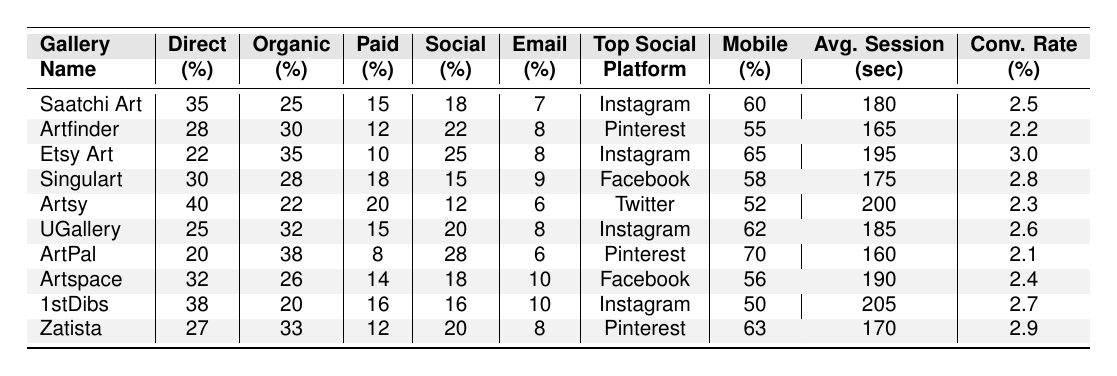What is the direct traffic percentage for Etsy Art? Referring to the table, the direct traffic percentage for Etsy Art is 22%.
Answer: 22% Which gallery has the highest percentage of organic search traffic? By examining the organic search traffic, Etsy Art has the highest percentage at 35%.
Answer: 35% What's the average conversion rate for all the galleries listed? To find the average conversion rate, sum all conversion rates: (2.5 + 2.2 + 3.0 + 2.8 + 2.3 + 2.6 + 2.1 + 2.4 + 2.7 + 2.9) = 27.0 and divide by 10, which equals 2.7.
Answer: 2.7 Is the top social media platform for Saatchi Art Instagram? Yes, the table indicates that the top social platform for Saatchi Art is Instagram.
Answer: Yes Which gallery has the lowest mobile traffic percentage? The gallery with the lowest mobile traffic percentage is 1stDibs, with a percentage of 50%.
Answer: 50% What is the difference in the direct traffic percentage between Artsy and UGallery? Artsy's direct traffic is 40%, and UGallery's is 25%. The difference is 40% - 25% = 15%.
Answer: 15% Does Artspace have a higher percentage of social media traffic compared to Artsy? Artspace has 18% social media traffic while Artsy has 12%. Therefore, Artspace has a higher percentage.
Answer: Yes What is the average session duration for all galleries, and which gallery has the longest duration? The average session duration can be found by summing the durations (180 + 165 + 195 + 175 + 200 + 185 + 160 + 190 + 205 + 170) = 1950 seconds, then dividing by 10 equals 195 seconds. The longest duration is 205 seconds for 1stDibs.
Answer: Average: 195 seconds, Longest: 205 seconds How many galleries have a conversion rate above 2.5%? The galleries with a conversion rate above 2.5% are Etsy Art (3.0%), Singulart (2.8%), UGallery (2.6%), 1stDibs (2.7%), and Zatista (2.9%). Thus, there are 5 galleries.
Answer: 5 Which gallery has the highest percentage of paid search traffic? Analyzing the table shows that Singulart has the highest paid search traffic percentage at 18%.
Answer: 18% 